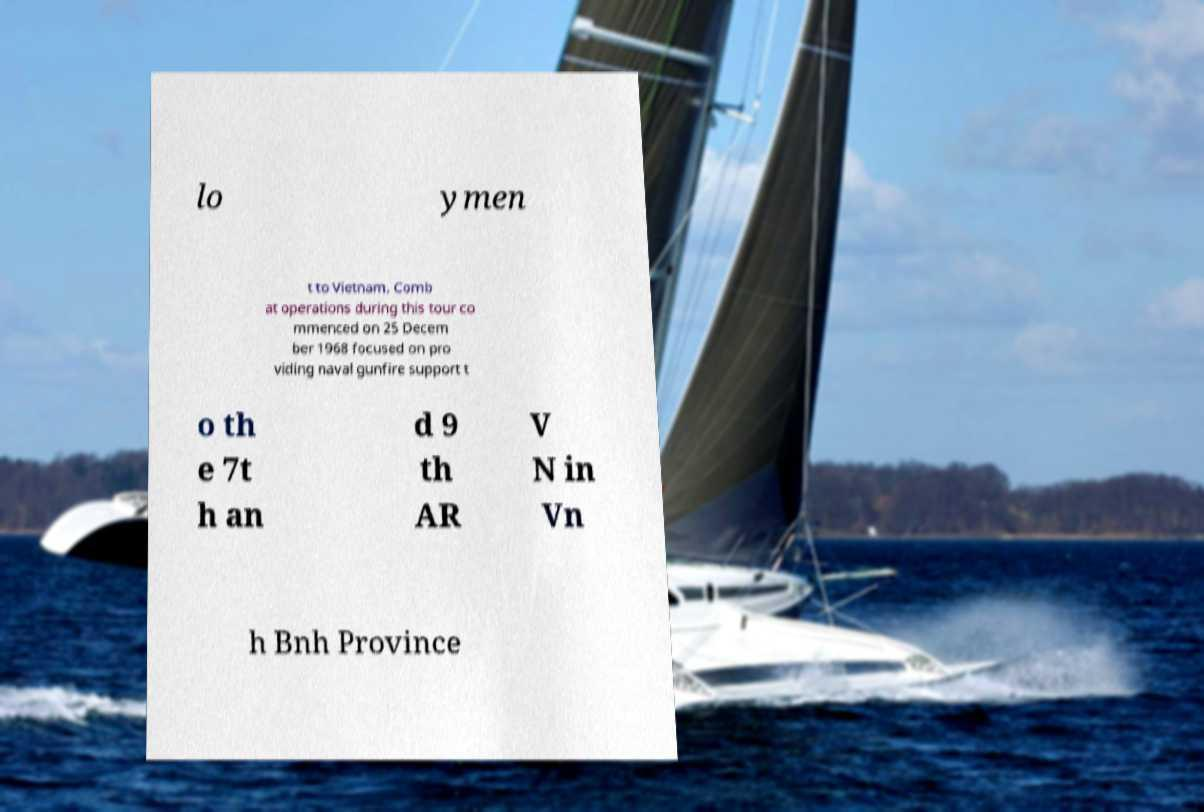For documentation purposes, I need the text within this image transcribed. Could you provide that? lo ymen t to Vietnam. Comb at operations during this tour co mmenced on 25 Decem ber 1968 focused on pro viding naval gunfire support t o th e 7t h an d 9 th AR V N in Vn h Bnh Province 